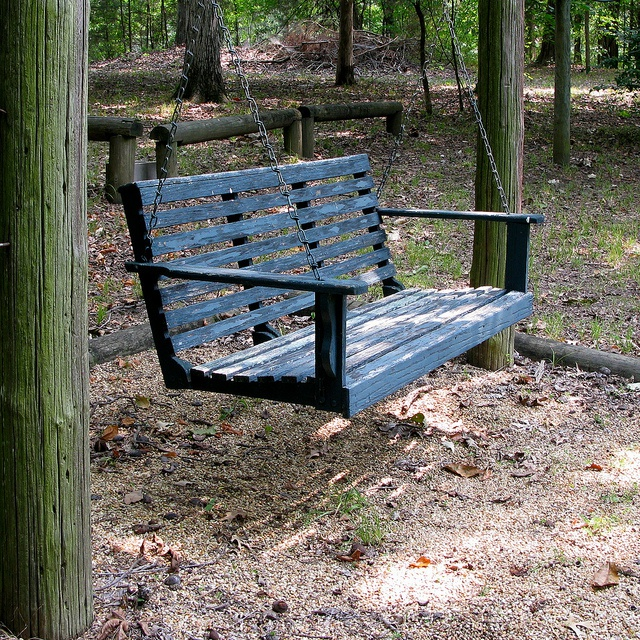Describe the objects in this image and their specific colors. I can see a bench in black and gray tones in this image. 